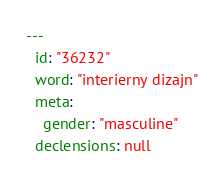Convert code to text. <code><loc_0><loc_0><loc_500><loc_500><_YAML_>---
  id: "36232"
  word: "interierny dizajn"
  meta: 
    gender: "masculine"
  declensions: null
</code> 